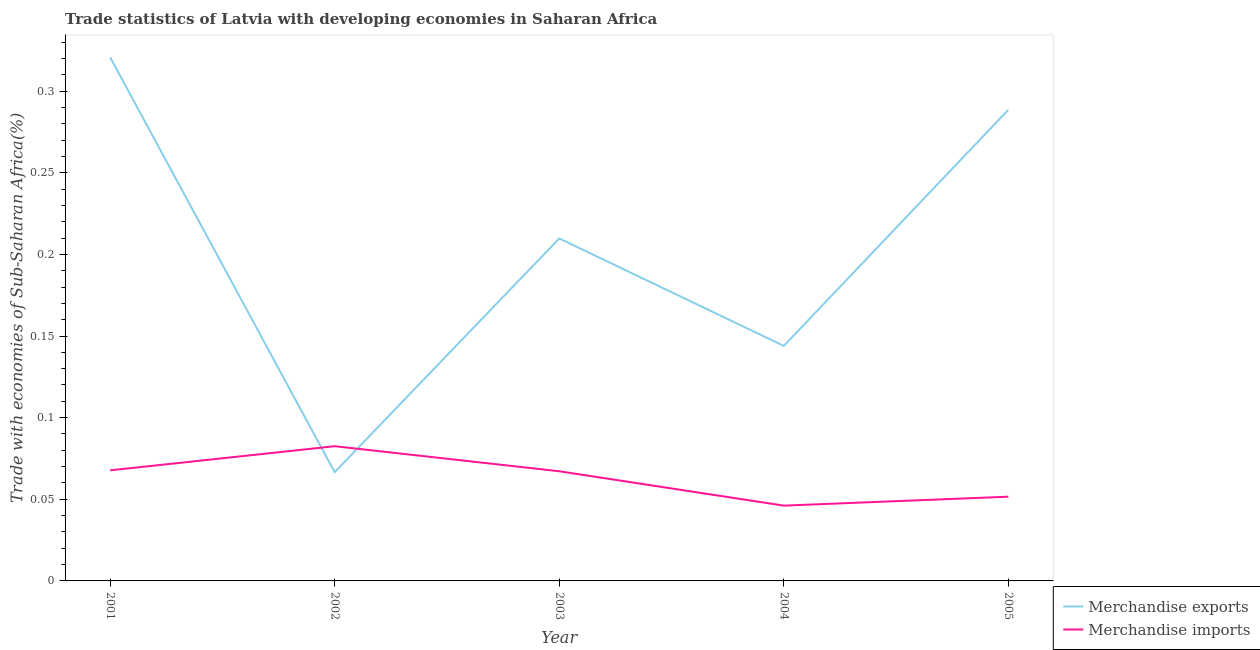How many different coloured lines are there?
Your response must be concise. 2. What is the merchandise exports in 2003?
Provide a succinct answer. 0.21. Across all years, what is the maximum merchandise imports?
Give a very brief answer. 0.08. Across all years, what is the minimum merchandise imports?
Give a very brief answer. 0.05. In which year was the merchandise exports maximum?
Your response must be concise. 2001. In which year was the merchandise imports minimum?
Make the answer very short. 2004. What is the total merchandise imports in the graph?
Give a very brief answer. 0.32. What is the difference between the merchandise imports in 2002 and that in 2005?
Offer a terse response. 0.03. What is the difference between the merchandise imports in 2003 and the merchandise exports in 2004?
Offer a terse response. -0.08. What is the average merchandise imports per year?
Offer a very short reply. 0.06. In the year 2002, what is the difference between the merchandise exports and merchandise imports?
Give a very brief answer. -0.02. In how many years, is the merchandise exports greater than 0.01 %?
Ensure brevity in your answer.  5. What is the ratio of the merchandise imports in 2002 to that in 2003?
Ensure brevity in your answer.  1.23. What is the difference between the highest and the second highest merchandise exports?
Offer a very short reply. 0.03. What is the difference between the highest and the lowest merchandise imports?
Your answer should be compact. 0.04. In how many years, is the merchandise exports greater than the average merchandise exports taken over all years?
Your answer should be very brief. 3. Is the merchandise exports strictly greater than the merchandise imports over the years?
Give a very brief answer. No. How many lines are there?
Your answer should be compact. 2. Are the values on the major ticks of Y-axis written in scientific E-notation?
Make the answer very short. No. Does the graph contain grids?
Offer a terse response. No. How many legend labels are there?
Provide a short and direct response. 2. What is the title of the graph?
Ensure brevity in your answer.  Trade statistics of Latvia with developing economies in Saharan Africa. What is the label or title of the X-axis?
Provide a succinct answer. Year. What is the label or title of the Y-axis?
Your answer should be compact. Trade with economies of Sub-Saharan Africa(%). What is the Trade with economies of Sub-Saharan Africa(%) in Merchandise exports in 2001?
Make the answer very short. 0.32. What is the Trade with economies of Sub-Saharan Africa(%) in Merchandise imports in 2001?
Keep it short and to the point. 0.07. What is the Trade with economies of Sub-Saharan Africa(%) of Merchandise exports in 2002?
Keep it short and to the point. 0.07. What is the Trade with economies of Sub-Saharan Africa(%) in Merchandise imports in 2002?
Keep it short and to the point. 0.08. What is the Trade with economies of Sub-Saharan Africa(%) in Merchandise exports in 2003?
Offer a terse response. 0.21. What is the Trade with economies of Sub-Saharan Africa(%) in Merchandise imports in 2003?
Provide a short and direct response. 0.07. What is the Trade with economies of Sub-Saharan Africa(%) in Merchandise exports in 2004?
Provide a succinct answer. 0.14. What is the Trade with economies of Sub-Saharan Africa(%) of Merchandise imports in 2004?
Ensure brevity in your answer.  0.05. What is the Trade with economies of Sub-Saharan Africa(%) of Merchandise exports in 2005?
Provide a succinct answer. 0.29. What is the Trade with economies of Sub-Saharan Africa(%) in Merchandise imports in 2005?
Keep it short and to the point. 0.05. Across all years, what is the maximum Trade with economies of Sub-Saharan Africa(%) in Merchandise exports?
Your answer should be compact. 0.32. Across all years, what is the maximum Trade with economies of Sub-Saharan Africa(%) in Merchandise imports?
Keep it short and to the point. 0.08. Across all years, what is the minimum Trade with economies of Sub-Saharan Africa(%) in Merchandise exports?
Keep it short and to the point. 0.07. Across all years, what is the minimum Trade with economies of Sub-Saharan Africa(%) of Merchandise imports?
Keep it short and to the point. 0.05. What is the total Trade with economies of Sub-Saharan Africa(%) in Merchandise exports in the graph?
Offer a very short reply. 1.03. What is the total Trade with economies of Sub-Saharan Africa(%) in Merchandise imports in the graph?
Ensure brevity in your answer.  0.32. What is the difference between the Trade with economies of Sub-Saharan Africa(%) of Merchandise exports in 2001 and that in 2002?
Your answer should be compact. 0.25. What is the difference between the Trade with economies of Sub-Saharan Africa(%) in Merchandise imports in 2001 and that in 2002?
Offer a terse response. -0.01. What is the difference between the Trade with economies of Sub-Saharan Africa(%) in Merchandise exports in 2001 and that in 2003?
Your response must be concise. 0.11. What is the difference between the Trade with economies of Sub-Saharan Africa(%) of Merchandise imports in 2001 and that in 2003?
Provide a succinct answer. 0. What is the difference between the Trade with economies of Sub-Saharan Africa(%) of Merchandise exports in 2001 and that in 2004?
Your answer should be compact. 0.18. What is the difference between the Trade with economies of Sub-Saharan Africa(%) of Merchandise imports in 2001 and that in 2004?
Provide a succinct answer. 0.02. What is the difference between the Trade with economies of Sub-Saharan Africa(%) of Merchandise exports in 2001 and that in 2005?
Ensure brevity in your answer.  0.03. What is the difference between the Trade with economies of Sub-Saharan Africa(%) in Merchandise imports in 2001 and that in 2005?
Provide a short and direct response. 0.02. What is the difference between the Trade with economies of Sub-Saharan Africa(%) of Merchandise exports in 2002 and that in 2003?
Offer a terse response. -0.14. What is the difference between the Trade with economies of Sub-Saharan Africa(%) of Merchandise imports in 2002 and that in 2003?
Make the answer very short. 0.02. What is the difference between the Trade with economies of Sub-Saharan Africa(%) in Merchandise exports in 2002 and that in 2004?
Provide a short and direct response. -0.08. What is the difference between the Trade with economies of Sub-Saharan Africa(%) in Merchandise imports in 2002 and that in 2004?
Give a very brief answer. 0.04. What is the difference between the Trade with economies of Sub-Saharan Africa(%) of Merchandise exports in 2002 and that in 2005?
Provide a succinct answer. -0.22. What is the difference between the Trade with economies of Sub-Saharan Africa(%) of Merchandise imports in 2002 and that in 2005?
Your response must be concise. 0.03. What is the difference between the Trade with economies of Sub-Saharan Africa(%) of Merchandise exports in 2003 and that in 2004?
Your answer should be compact. 0.07. What is the difference between the Trade with economies of Sub-Saharan Africa(%) in Merchandise imports in 2003 and that in 2004?
Ensure brevity in your answer.  0.02. What is the difference between the Trade with economies of Sub-Saharan Africa(%) of Merchandise exports in 2003 and that in 2005?
Your answer should be very brief. -0.08. What is the difference between the Trade with economies of Sub-Saharan Africa(%) in Merchandise imports in 2003 and that in 2005?
Your response must be concise. 0.02. What is the difference between the Trade with economies of Sub-Saharan Africa(%) in Merchandise exports in 2004 and that in 2005?
Provide a short and direct response. -0.14. What is the difference between the Trade with economies of Sub-Saharan Africa(%) of Merchandise imports in 2004 and that in 2005?
Make the answer very short. -0.01. What is the difference between the Trade with economies of Sub-Saharan Africa(%) of Merchandise exports in 2001 and the Trade with economies of Sub-Saharan Africa(%) of Merchandise imports in 2002?
Offer a very short reply. 0.24. What is the difference between the Trade with economies of Sub-Saharan Africa(%) in Merchandise exports in 2001 and the Trade with economies of Sub-Saharan Africa(%) in Merchandise imports in 2003?
Provide a succinct answer. 0.25. What is the difference between the Trade with economies of Sub-Saharan Africa(%) of Merchandise exports in 2001 and the Trade with economies of Sub-Saharan Africa(%) of Merchandise imports in 2004?
Give a very brief answer. 0.27. What is the difference between the Trade with economies of Sub-Saharan Africa(%) in Merchandise exports in 2001 and the Trade with economies of Sub-Saharan Africa(%) in Merchandise imports in 2005?
Your answer should be very brief. 0.27. What is the difference between the Trade with economies of Sub-Saharan Africa(%) of Merchandise exports in 2002 and the Trade with economies of Sub-Saharan Africa(%) of Merchandise imports in 2003?
Ensure brevity in your answer.  -0. What is the difference between the Trade with economies of Sub-Saharan Africa(%) in Merchandise exports in 2002 and the Trade with economies of Sub-Saharan Africa(%) in Merchandise imports in 2004?
Offer a terse response. 0.02. What is the difference between the Trade with economies of Sub-Saharan Africa(%) in Merchandise exports in 2002 and the Trade with economies of Sub-Saharan Africa(%) in Merchandise imports in 2005?
Your answer should be very brief. 0.01. What is the difference between the Trade with economies of Sub-Saharan Africa(%) in Merchandise exports in 2003 and the Trade with economies of Sub-Saharan Africa(%) in Merchandise imports in 2004?
Your response must be concise. 0.16. What is the difference between the Trade with economies of Sub-Saharan Africa(%) in Merchandise exports in 2003 and the Trade with economies of Sub-Saharan Africa(%) in Merchandise imports in 2005?
Your answer should be very brief. 0.16. What is the difference between the Trade with economies of Sub-Saharan Africa(%) of Merchandise exports in 2004 and the Trade with economies of Sub-Saharan Africa(%) of Merchandise imports in 2005?
Your answer should be compact. 0.09. What is the average Trade with economies of Sub-Saharan Africa(%) of Merchandise exports per year?
Your answer should be compact. 0.21. What is the average Trade with economies of Sub-Saharan Africa(%) of Merchandise imports per year?
Your answer should be compact. 0.06. In the year 2001, what is the difference between the Trade with economies of Sub-Saharan Africa(%) in Merchandise exports and Trade with economies of Sub-Saharan Africa(%) in Merchandise imports?
Provide a succinct answer. 0.25. In the year 2002, what is the difference between the Trade with economies of Sub-Saharan Africa(%) in Merchandise exports and Trade with economies of Sub-Saharan Africa(%) in Merchandise imports?
Provide a succinct answer. -0.02. In the year 2003, what is the difference between the Trade with economies of Sub-Saharan Africa(%) in Merchandise exports and Trade with economies of Sub-Saharan Africa(%) in Merchandise imports?
Offer a very short reply. 0.14. In the year 2004, what is the difference between the Trade with economies of Sub-Saharan Africa(%) in Merchandise exports and Trade with economies of Sub-Saharan Africa(%) in Merchandise imports?
Your response must be concise. 0.1. In the year 2005, what is the difference between the Trade with economies of Sub-Saharan Africa(%) in Merchandise exports and Trade with economies of Sub-Saharan Africa(%) in Merchandise imports?
Keep it short and to the point. 0.24. What is the ratio of the Trade with economies of Sub-Saharan Africa(%) of Merchandise exports in 2001 to that in 2002?
Make the answer very short. 4.82. What is the ratio of the Trade with economies of Sub-Saharan Africa(%) in Merchandise imports in 2001 to that in 2002?
Your answer should be compact. 0.82. What is the ratio of the Trade with economies of Sub-Saharan Africa(%) in Merchandise exports in 2001 to that in 2003?
Your answer should be very brief. 1.53. What is the ratio of the Trade with economies of Sub-Saharan Africa(%) in Merchandise imports in 2001 to that in 2003?
Keep it short and to the point. 1.01. What is the ratio of the Trade with economies of Sub-Saharan Africa(%) in Merchandise exports in 2001 to that in 2004?
Ensure brevity in your answer.  2.23. What is the ratio of the Trade with economies of Sub-Saharan Africa(%) of Merchandise imports in 2001 to that in 2004?
Your answer should be very brief. 1.47. What is the ratio of the Trade with economies of Sub-Saharan Africa(%) in Merchandise exports in 2001 to that in 2005?
Keep it short and to the point. 1.11. What is the ratio of the Trade with economies of Sub-Saharan Africa(%) of Merchandise imports in 2001 to that in 2005?
Ensure brevity in your answer.  1.31. What is the ratio of the Trade with economies of Sub-Saharan Africa(%) in Merchandise exports in 2002 to that in 2003?
Ensure brevity in your answer.  0.32. What is the ratio of the Trade with economies of Sub-Saharan Africa(%) of Merchandise imports in 2002 to that in 2003?
Your answer should be very brief. 1.23. What is the ratio of the Trade with economies of Sub-Saharan Africa(%) of Merchandise exports in 2002 to that in 2004?
Your response must be concise. 0.46. What is the ratio of the Trade with economies of Sub-Saharan Africa(%) in Merchandise imports in 2002 to that in 2004?
Offer a terse response. 1.79. What is the ratio of the Trade with economies of Sub-Saharan Africa(%) in Merchandise exports in 2002 to that in 2005?
Provide a succinct answer. 0.23. What is the ratio of the Trade with economies of Sub-Saharan Africa(%) in Merchandise imports in 2002 to that in 2005?
Give a very brief answer. 1.6. What is the ratio of the Trade with economies of Sub-Saharan Africa(%) of Merchandise exports in 2003 to that in 2004?
Your response must be concise. 1.46. What is the ratio of the Trade with economies of Sub-Saharan Africa(%) in Merchandise imports in 2003 to that in 2004?
Your response must be concise. 1.46. What is the ratio of the Trade with economies of Sub-Saharan Africa(%) of Merchandise exports in 2003 to that in 2005?
Provide a succinct answer. 0.73. What is the ratio of the Trade with economies of Sub-Saharan Africa(%) of Merchandise imports in 2003 to that in 2005?
Your answer should be compact. 1.3. What is the ratio of the Trade with economies of Sub-Saharan Africa(%) in Merchandise exports in 2004 to that in 2005?
Your answer should be compact. 0.5. What is the ratio of the Trade with economies of Sub-Saharan Africa(%) of Merchandise imports in 2004 to that in 2005?
Your answer should be very brief. 0.89. What is the difference between the highest and the second highest Trade with economies of Sub-Saharan Africa(%) of Merchandise exports?
Keep it short and to the point. 0.03. What is the difference between the highest and the second highest Trade with economies of Sub-Saharan Africa(%) of Merchandise imports?
Provide a succinct answer. 0.01. What is the difference between the highest and the lowest Trade with economies of Sub-Saharan Africa(%) in Merchandise exports?
Ensure brevity in your answer.  0.25. What is the difference between the highest and the lowest Trade with economies of Sub-Saharan Africa(%) in Merchandise imports?
Your answer should be very brief. 0.04. 